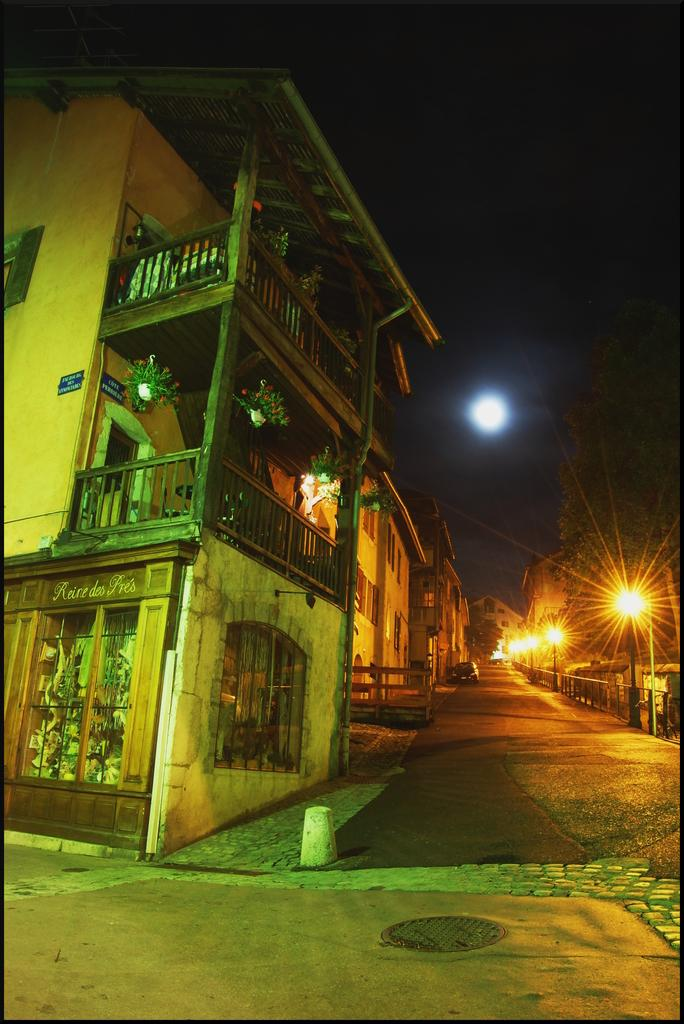What structures are located on the left side of the image? There are buildings on the left side of the image. What can be seen in the background of the image? There is a car in the background of the image. What is present on the right side of the image? There are lights and trees on the right side of the image. What celestial body is visible in the sky at the top of the image? The moon is visible in the sky at the top of the image. How many letters are visible on the car in the image? There are no letters visible on the car in the image. What type of bone can be seen in the image? There is no bone present in the image. 